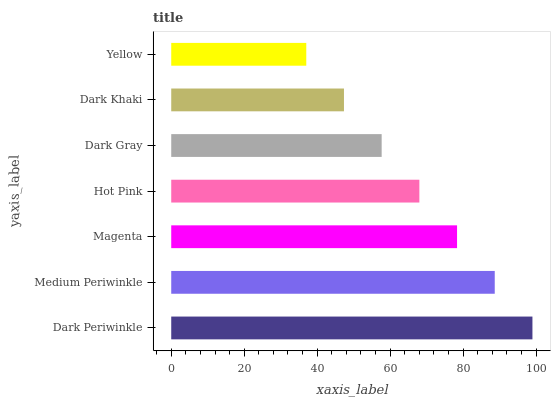Is Yellow the minimum?
Answer yes or no. Yes. Is Dark Periwinkle the maximum?
Answer yes or no. Yes. Is Medium Periwinkle the minimum?
Answer yes or no. No. Is Medium Periwinkle the maximum?
Answer yes or no. No. Is Dark Periwinkle greater than Medium Periwinkle?
Answer yes or no. Yes. Is Medium Periwinkle less than Dark Periwinkle?
Answer yes or no. Yes. Is Medium Periwinkle greater than Dark Periwinkle?
Answer yes or no. No. Is Dark Periwinkle less than Medium Periwinkle?
Answer yes or no. No. Is Hot Pink the high median?
Answer yes or no. Yes. Is Hot Pink the low median?
Answer yes or no. Yes. Is Dark Periwinkle the high median?
Answer yes or no. No. Is Dark Gray the low median?
Answer yes or no. No. 